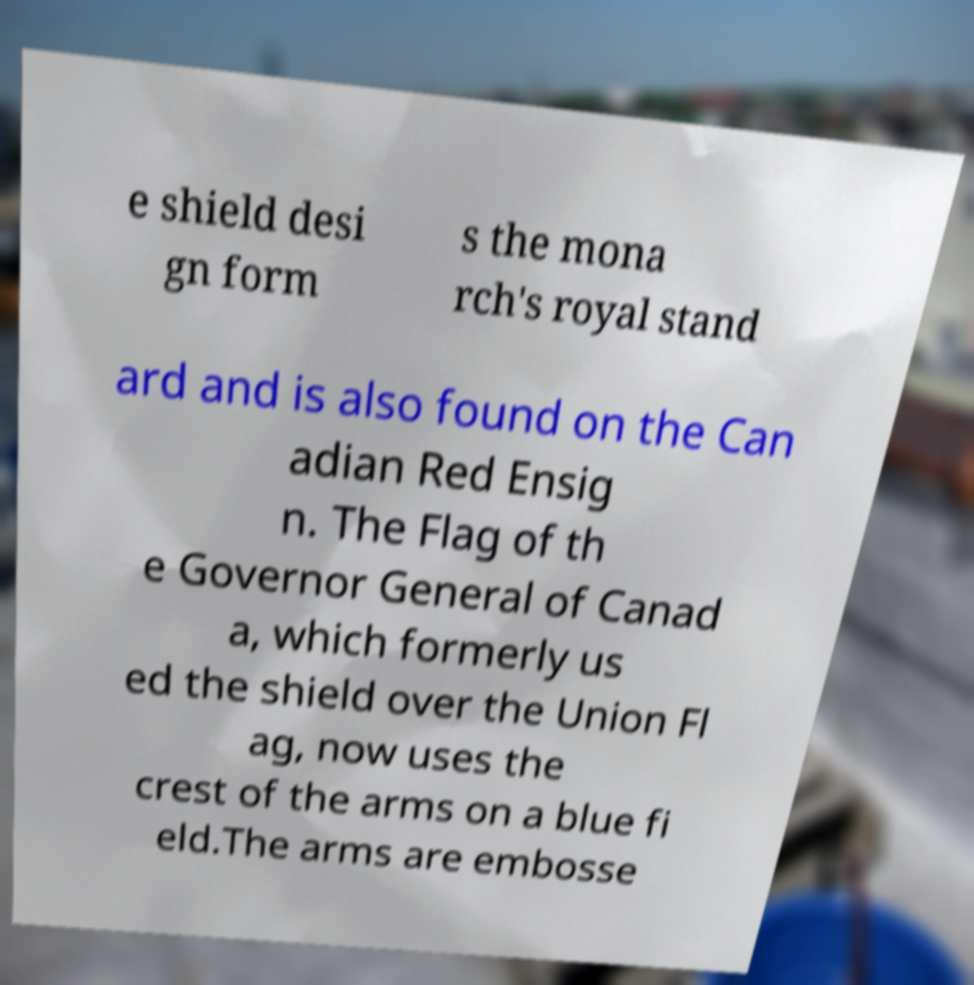Please identify and transcribe the text found in this image. e shield desi gn form s the mona rch's royal stand ard and is also found on the Can adian Red Ensig n. The Flag of th e Governor General of Canad a, which formerly us ed the shield over the Union Fl ag, now uses the crest of the arms on a blue fi eld.The arms are embosse 